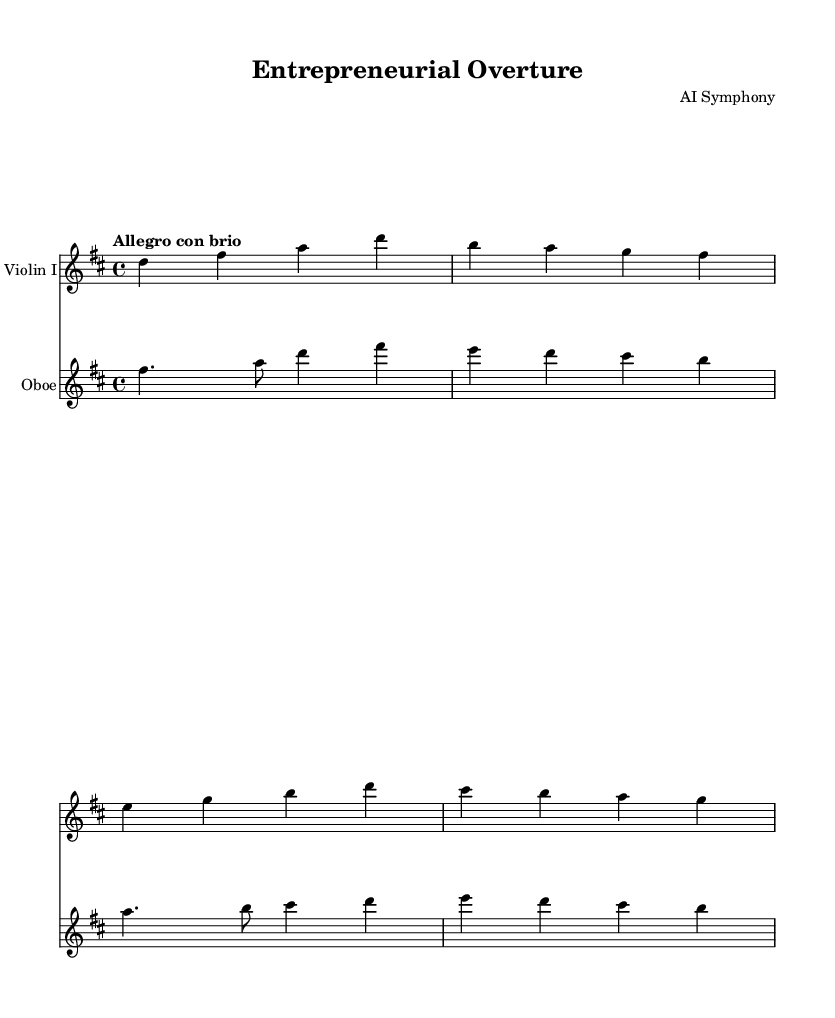What is the title of the piece? The title is given in the header section of the sheet music, identified by the line that states "title = "Entrepreneurial Overture"."
Answer: Entrepreneurial Overture What is the key signature of this music? The key signature can be identified at the beginning of the score and indicates D major, which contains two sharps (F# and C#).
Answer: D major What is the time signature? The time signature is located next to the clef at the start of the music, which shows it as 4/4.
Answer: 4/4 What is the tempo marking for the piece? The tempo marking is indicated in the global section, specifically noted as "Allegro con brio," which signifies a fast and lively tempo.
Answer: Allegro con brio How many instruments are featured in this score? The score includes two different staves, each representing a distinct instrument (Violin I and Oboe), indicating that there are two instruments involved.
Answer: 2 Which instrument's part appears first in the score? The first staff in the score is dedicated to Violin I, as indicated by the instrument name at the beginning of that staff.
Answer: Violin I What is the rhythmic value of the note on the first beat of the violin part? The first note of the violin part is a quarter note (d4), which can be located at the beginning of the measure.
Answer: Quarter note 